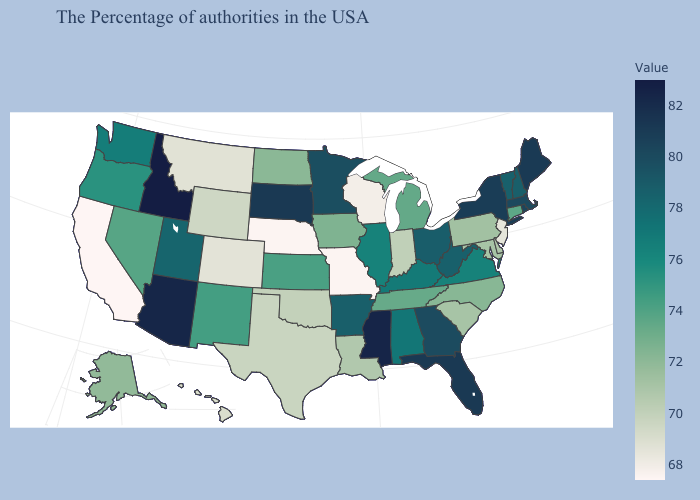Does Oklahoma have a lower value than Minnesota?
Keep it brief. Yes. Does Ohio have the lowest value in the USA?
Give a very brief answer. No. Does Michigan have a higher value than Maine?
Short answer required. No. Does Michigan have the lowest value in the MidWest?
Be succinct. No. Does Oklahoma have a lower value than Wisconsin?
Give a very brief answer. No. 